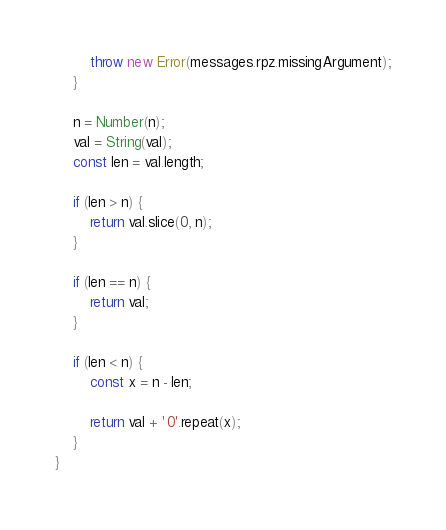<code> <loc_0><loc_0><loc_500><loc_500><_JavaScript_>        throw new Error(messages.rpz.missingArgument);
    }

    n = Number(n);
    val = String(val);
    const len = val.length;

    if (len > n) {
        return val.slice(0, n);
    }

    if (len == n) {
        return val;
    }

    if (len < n) {
        const x = n - len;

        return val + '0'.repeat(x);
    }
}
</code> 